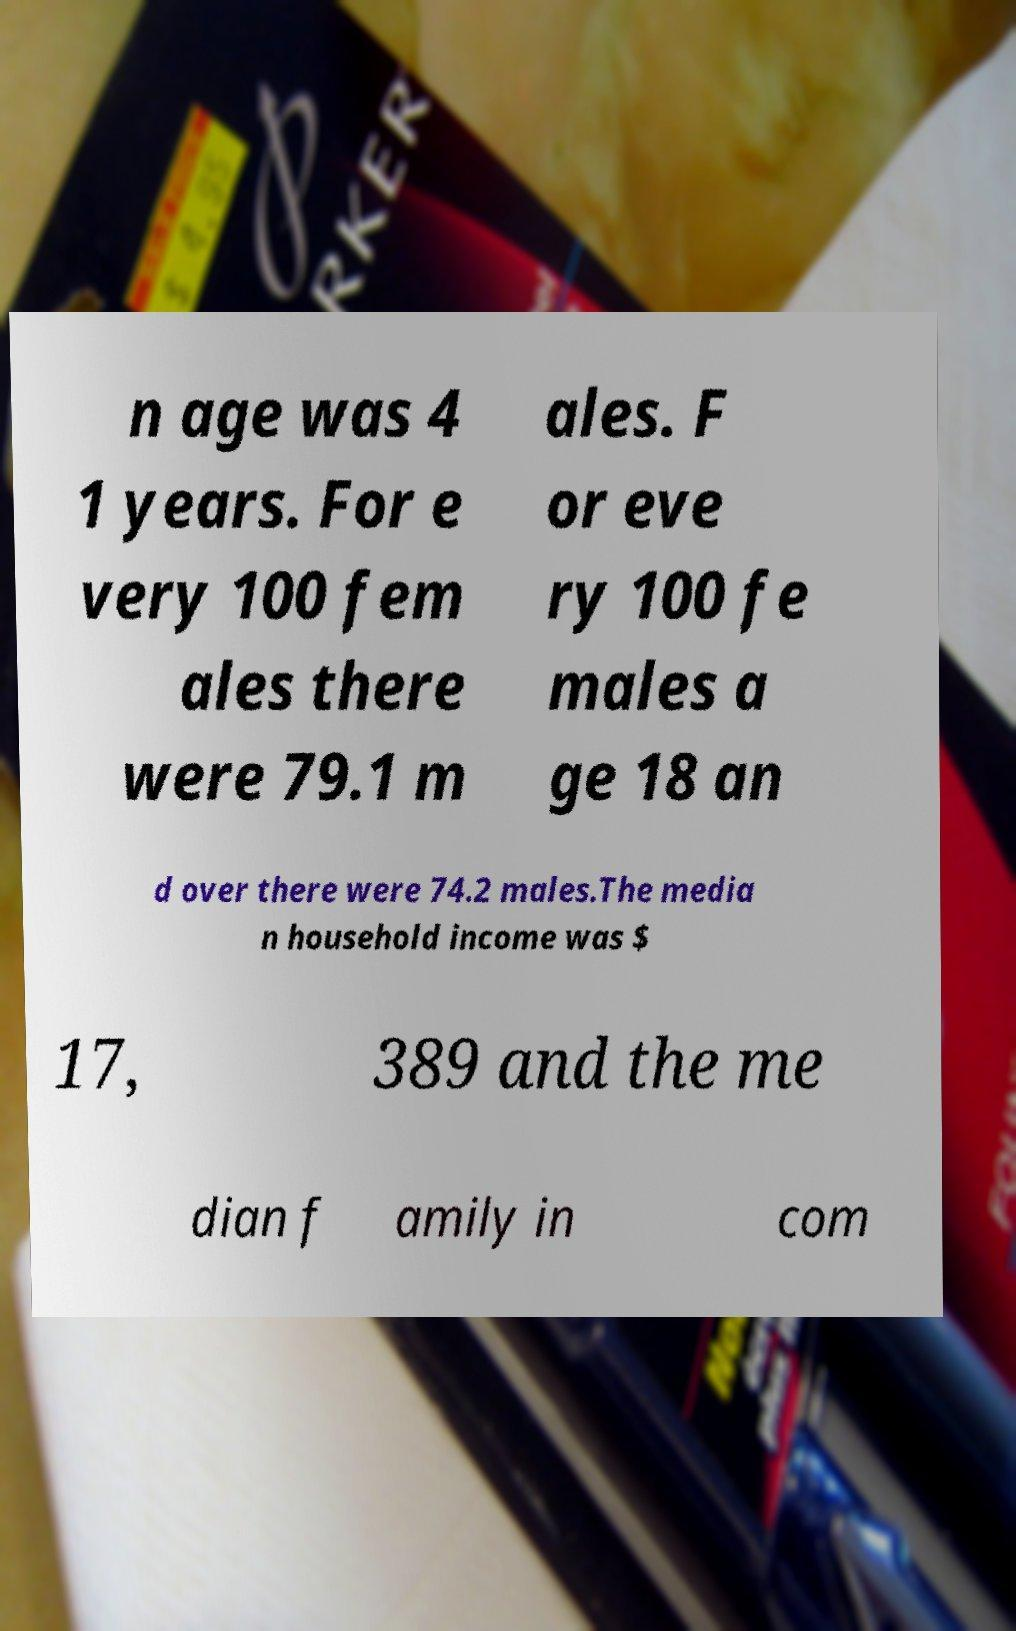There's text embedded in this image that I need extracted. Can you transcribe it verbatim? n age was 4 1 years. For e very 100 fem ales there were 79.1 m ales. F or eve ry 100 fe males a ge 18 an d over there were 74.2 males.The media n household income was $ 17, 389 and the me dian f amily in com 